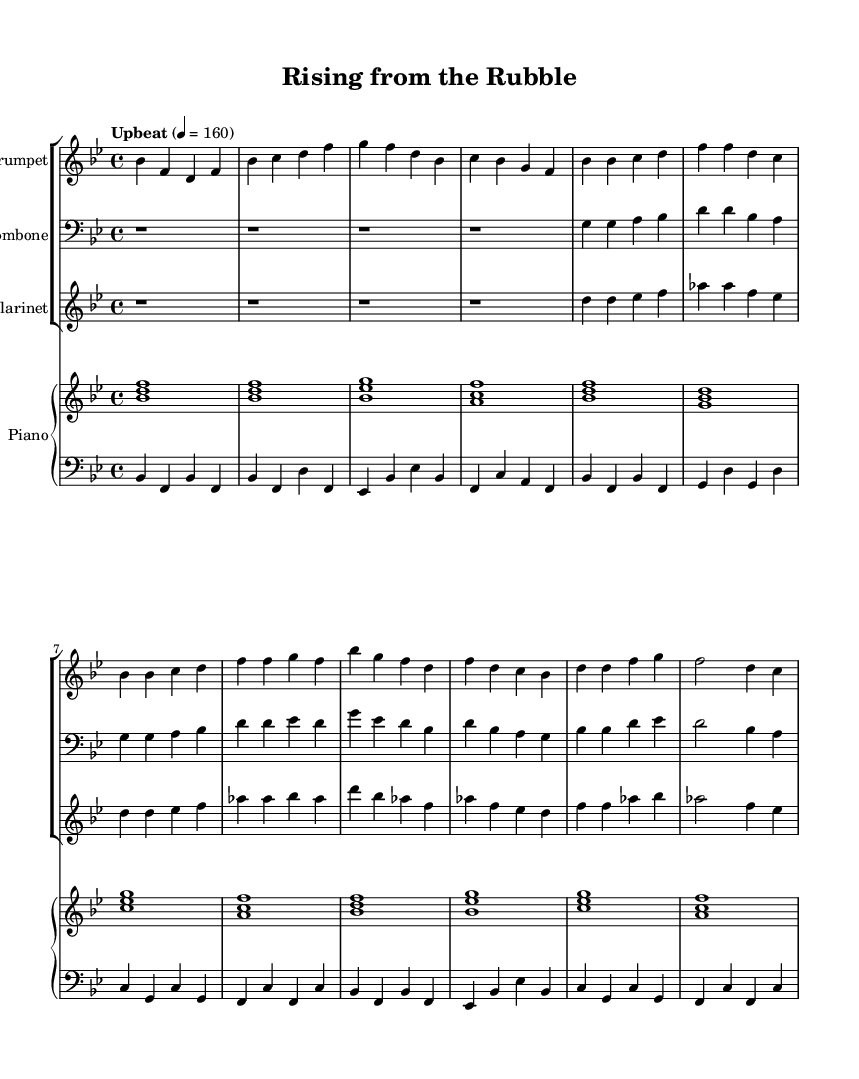What is the key signature of this music? The key signature is indicated by the presence of two flats, which is characteristic of B flat major.
Answer: B flat major What is the time signature of the piece? The time signature is displayed at the beginning of the score, indicating that there are four beats per measure, which is typical for jazz music.
Answer: 4/4 What is the tempo marking of the music? The tempo marking is specified above the staff, setting the speed at 160 beats per minute and is marked as "Upbeat."
Answer: Upbeat How many measures are in the intro section? By examining the music, we can count the number of measures in the intro, which consists of four measures in total.
Answer: 4 What instruments are included in this piece? The score features three instruments in the ensemble: trumpet, trombone, and clarinet, along with a piano part.
Answer: Trumpet, Trombone, Clarinet, Piano Which instrument has the first music line in the score? The first part to sound is the trumpet, as it starts playing the intro notes, setting the stage for the piece.
Answer: Trumpet What section of the music does the trombone play in? The trombone plays a simplified part, marked as a bass clef, indicating its role in providing harmonies and foundational notes.
Answer: Bass clef 